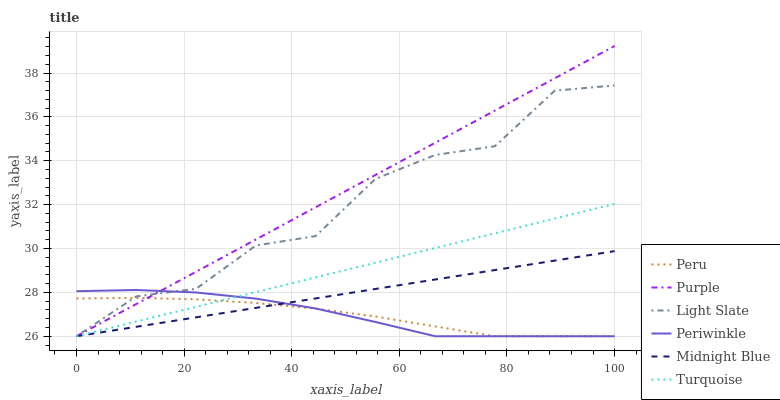Does Peru have the minimum area under the curve?
Answer yes or no. Yes. Does Purple have the maximum area under the curve?
Answer yes or no. Yes. Does Midnight Blue have the minimum area under the curve?
Answer yes or no. No. Does Midnight Blue have the maximum area under the curve?
Answer yes or no. No. Is Midnight Blue the smoothest?
Answer yes or no. Yes. Is Light Slate the roughest?
Answer yes or no. Yes. Is Purple the smoothest?
Answer yes or no. No. Is Purple the roughest?
Answer yes or no. No. Does Turquoise have the lowest value?
Answer yes or no. Yes. Does Purple have the highest value?
Answer yes or no. Yes. Does Midnight Blue have the highest value?
Answer yes or no. No. Does Midnight Blue intersect Light Slate?
Answer yes or no. Yes. Is Midnight Blue less than Light Slate?
Answer yes or no. No. Is Midnight Blue greater than Light Slate?
Answer yes or no. No. 